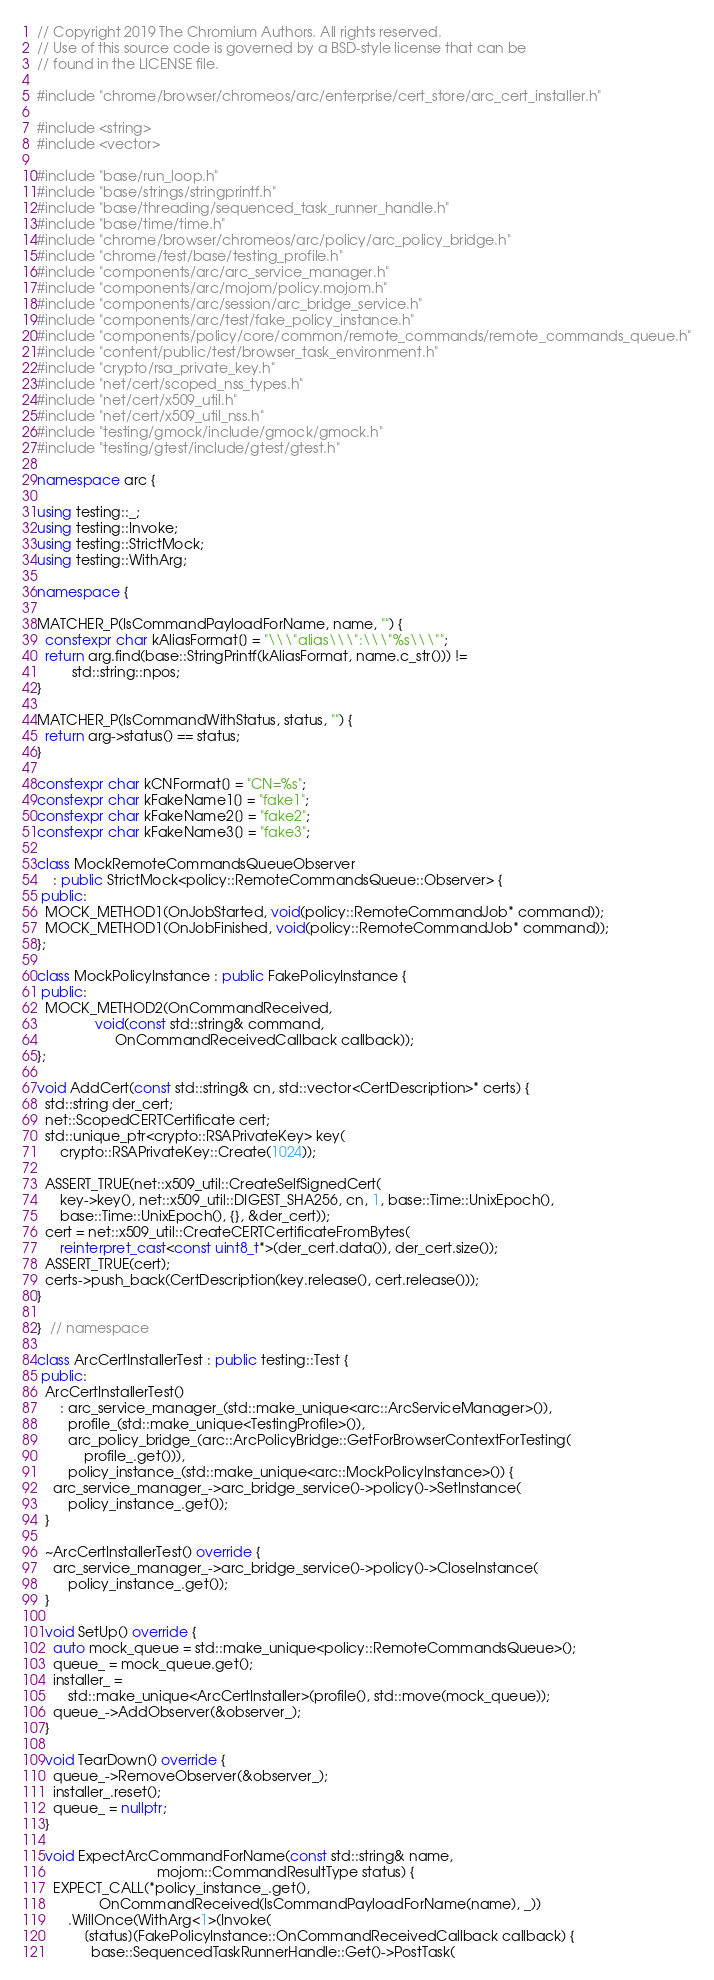<code> <loc_0><loc_0><loc_500><loc_500><_C++_>// Copyright 2019 The Chromium Authors. All rights reserved.
// Use of this source code is governed by a BSD-style license that can be
// found in the LICENSE file.

#include "chrome/browser/chromeos/arc/enterprise/cert_store/arc_cert_installer.h"

#include <string>
#include <vector>

#include "base/run_loop.h"
#include "base/strings/stringprintf.h"
#include "base/threading/sequenced_task_runner_handle.h"
#include "base/time/time.h"
#include "chrome/browser/chromeos/arc/policy/arc_policy_bridge.h"
#include "chrome/test/base/testing_profile.h"
#include "components/arc/arc_service_manager.h"
#include "components/arc/mojom/policy.mojom.h"
#include "components/arc/session/arc_bridge_service.h"
#include "components/arc/test/fake_policy_instance.h"
#include "components/policy/core/common/remote_commands/remote_commands_queue.h"
#include "content/public/test/browser_task_environment.h"
#include "crypto/rsa_private_key.h"
#include "net/cert/scoped_nss_types.h"
#include "net/cert/x509_util.h"
#include "net/cert/x509_util_nss.h"
#include "testing/gmock/include/gmock/gmock.h"
#include "testing/gtest/include/gtest/gtest.h"

namespace arc {

using testing::_;
using testing::Invoke;
using testing::StrictMock;
using testing::WithArg;

namespace {

MATCHER_P(IsCommandPayloadForName, name, "") {
  constexpr char kAliasFormat[] = "\\\"alias\\\":\\\"%s\\\"";
  return arg.find(base::StringPrintf(kAliasFormat, name.c_str())) !=
         std::string::npos;
}

MATCHER_P(IsCommandWithStatus, status, "") {
  return arg->status() == status;
}

constexpr char kCNFormat[] = "CN=%s";
constexpr char kFakeName1[] = "fake1";
constexpr char kFakeName2[] = "fake2";
constexpr char kFakeName3[] = "fake3";

class MockRemoteCommandsQueueObserver
    : public StrictMock<policy::RemoteCommandsQueue::Observer> {
 public:
  MOCK_METHOD1(OnJobStarted, void(policy::RemoteCommandJob* command));
  MOCK_METHOD1(OnJobFinished, void(policy::RemoteCommandJob* command));
};

class MockPolicyInstance : public FakePolicyInstance {
 public:
  MOCK_METHOD2(OnCommandReceived,
               void(const std::string& command,
                    OnCommandReceivedCallback callback));
};

void AddCert(const std::string& cn, std::vector<CertDescription>* certs) {
  std::string der_cert;
  net::ScopedCERTCertificate cert;
  std::unique_ptr<crypto::RSAPrivateKey> key(
      crypto::RSAPrivateKey::Create(1024));

  ASSERT_TRUE(net::x509_util::CreateSelfSignedCert(
      key->key(), net::x509_util::DIGEST_SHA256, cn, 1, base::Time::UnixEpoch(),
      base::Time::UnixEpoch(), {}, &der_cert));
  cert = net::x509_util::CreateCERTCertificateFromBytes(
      reinterpret_cast<const uint8_t*>(der_cert.data()), der_cert.size());
  ASSERT_TRUE(cert);
  certs->push_back(CertDescription(key.release(), cert.release()));
}

}  // namespace

class ArcCertInstallerTest : public testing::Test {
 public:
  ArcCertInstallerTest()
      : arc_service_manager_(std::make_unique<arc::ArcServiceManager>()),
        profile_(std::make_unique<TestingProfile>()),
        arc_policy_bridge_(arc::ArcPolicyBridge::GetForBrowserContextForTesting(
            profile_.get())),
        policy_instance_(std::make_unique<arc::MockPolicyInstance>()) {
    arc_service_manager_->arc_bridge_service()->policy()->SetInstance(
        policy_instance_.get());
  }

  ~ArcCertInstallerTest() override {
    arc_service_manager_->arc_bridge_service()->policy()->CloseInstance(
        policy_instance_.get());
  }

  void SetUp() override {
    auto mock_queue = std::make_unique<policy::RemoteCommandsQueue>();
    queue_ = mock_queue.get();
    installer_ =
        std::make_unique<ArcCertInstaller>(profile(), std::move(mock_queue));
    queue_->AddObserver(&observer_);
  }

  void TearDown() override {
    queue_->RemoveObserver(&observer_);
    installer_.reset();
    queue_ = nullptr;
  }

  void ExpectArcCommandForName(const std::string& name,
                               mojom::CommandResultType status) {
    EXPECT_CALL(*policy_instance_.get(),
                OnCommandReceived(IsCommandPayloadForName(name), _))
        .WillOnce(WithArg<1>(Invoke(
            [status](FakePolicyInstance::OnCommandReceivedCallback callback) {
              base::SequencedTaskRunnerHandle::Get()->PostTask(</code> 